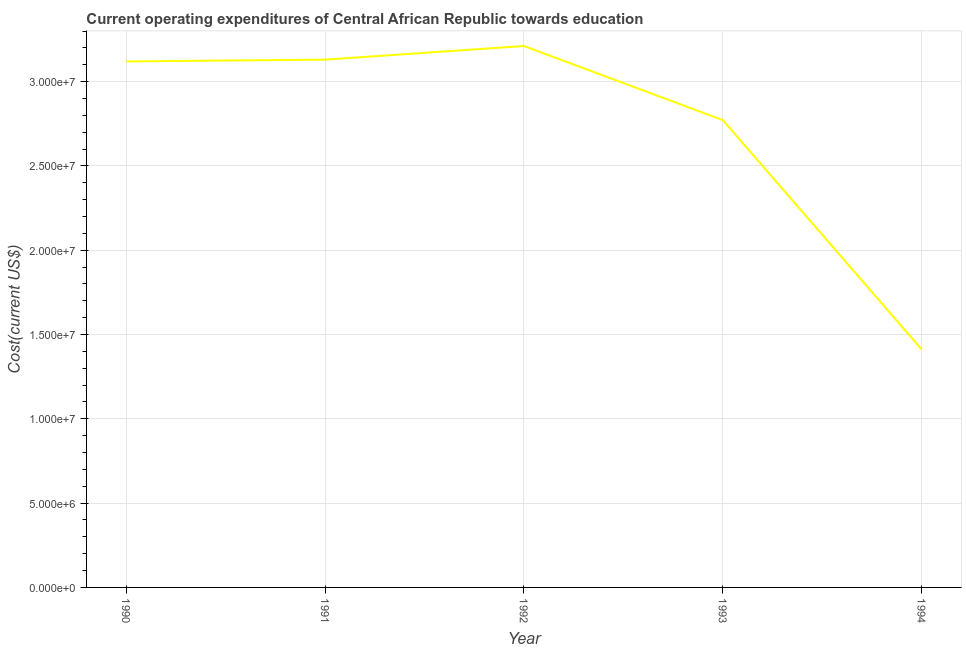What is the education expenditure in 1991?
Offer a terse response. 3.13e+07. Across all years, what is the maximum education expenditure?
Your answer should be compact. 3.21e+07. Across all years, what is the minimum education expenditure?
Make the answer very short. 1.41e+07. In which year was the education expenditure maximum?
Offer a terse response. 1992. What is the sum of the education expenditure?
Keep it short and to the point. 1.36e+08. What is the difference between the education expenditure in 1991 and 1994?
Your response must be concise. 1.72e+07. What is the average education expenditure per year?
Your response must be concise. 2.73e+07. What is the median education expenditure?
Give a very brief answer. 3.12e+07. What is the ratio of the education expenditure in 1990 to that in 1991?
Offer a very short reply. 1. Is the education expenditure in 1990 less than that in 1993?
Provide a succinct answer. No. What is the difference between the highest and the second highest education expenditure?
Provide a short and direct response. 8.09e+05. Is the sum of the education expenditure in 1990 and 1994 greater than the maximum education expenditure across all years?
Give a very brief answer. Yes. What is the difference between the highest and the lowest education expenditure?
Make the answer very short. 1.80e+07. Does the education expenditure monotonically increase over the years?
Offer a terse response. No. What is the title of the graph?
Keep it short and to the point. Current operating expenditures of Central African Republic towards education. What is the label or title of the Y-axis?
Make the answer very short. Cost(current US$). What is the Cost(current US$) in 1990?
Provide a short and direct response. 3.12e+07. What is the Cost(current US$) of 1991?
Offer a very short reply. 3.13e+07. What is the Cost(current US$) of 1992?
Give a very brief answer. 3.21e+07. What is the Cost(current US$) in 1993?
Give a very brief answer. 2.77e+07. What is the Cost(current US$) in 1994?
Make the answer very short. 1.41e+07. What is the difference between the Cost(current US$) in 1990 and 1991?
Provide a succinct answer. -1.07e+05. What is the difference between the Cost(current US$) in 1990 and 1992?
Your response must be concise. -9.16e+05. What is the difference between the Cost(current US$) in 1990 and 1993?
Make the answer very short. 3.48e+06. What is the difference between the Cost(current US$) in 1990 and 1994?
Your answer should be compact. 1.71e+07. What is the difference between the Cost(current US$) in 1991 and 1992?
Provide a succinct answer. -8.09e+05. What is the difference between the Cost(current US$) in 1991 and 1993?
Ensure brevity in your answer.  3.59e+06. What is the difference between the Cost(current US$) in 1991 and 1994?
Your answer should be very brief. 1.72e+07. What is the difference between the Cost(current US$) in 1992 and 1993?
Offer a very short reply. 4.40e+06. What is the difference between the Cost(current US$) in 1992 and 1994?
Your answer should be compact. 1.80e+07. What is the difference between the Cost(current US$) in 1993 and 1994?
Provide a succinct answer. 1.36e+07. What is the ratio of the Cost(current US$) in 1990 to that in 1993?
Provide a succinct answer. 1.13. What is the ratio of the Cost(current US$) in 1990 to that in 1994?
Provide a short and direct response. 2.21. What is the ratio of the Cost(current US$) in 1991 to that in 1992?
Keep it short and to the point. 0.97. What is the ratio of the Cost(current US$) in 1991 to that in 1993?
Give a very brief answer. 1.13. What is the ratio of the Cost(current US$) in 1991 to that in 1994?
Provide a short and direct response. 2.22. What is the ratio of the Cost(current US$) in 1992 to that in 1993?
Offer a terse response. 1.16. What is the ratio of the Cost(current US$) in 1992 to that in 1994?
Provide a short and direct response. 2.27. What is the ratio of the Cost(current US$) in 1993 to that in 1994?
Offer a terse response. 1.96. 